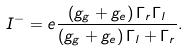Convert formula to latex. <formula><loc_0><loc_0><loc_500><loc_500>I ^ { - } = e \frac { \left ( g _ { g } + g _ { e } \right ) \Gamma _ { r } \Gamma _ { l } } { \left ( g _ { g } + g _ { e } \right ) \Gamma _ { l } + \Gamma _ { r } } .</formula> 